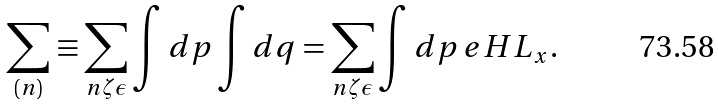<formula> <loc_0><loc_0><loc_500><loc_500>\sum _ { ( n ) } \equiv \sum _ { n \zeta \epsilon } \int d p \int d q = \sum _ { n \zeta \epsilon } \int d p \, e H L _ { x } .</formula> 